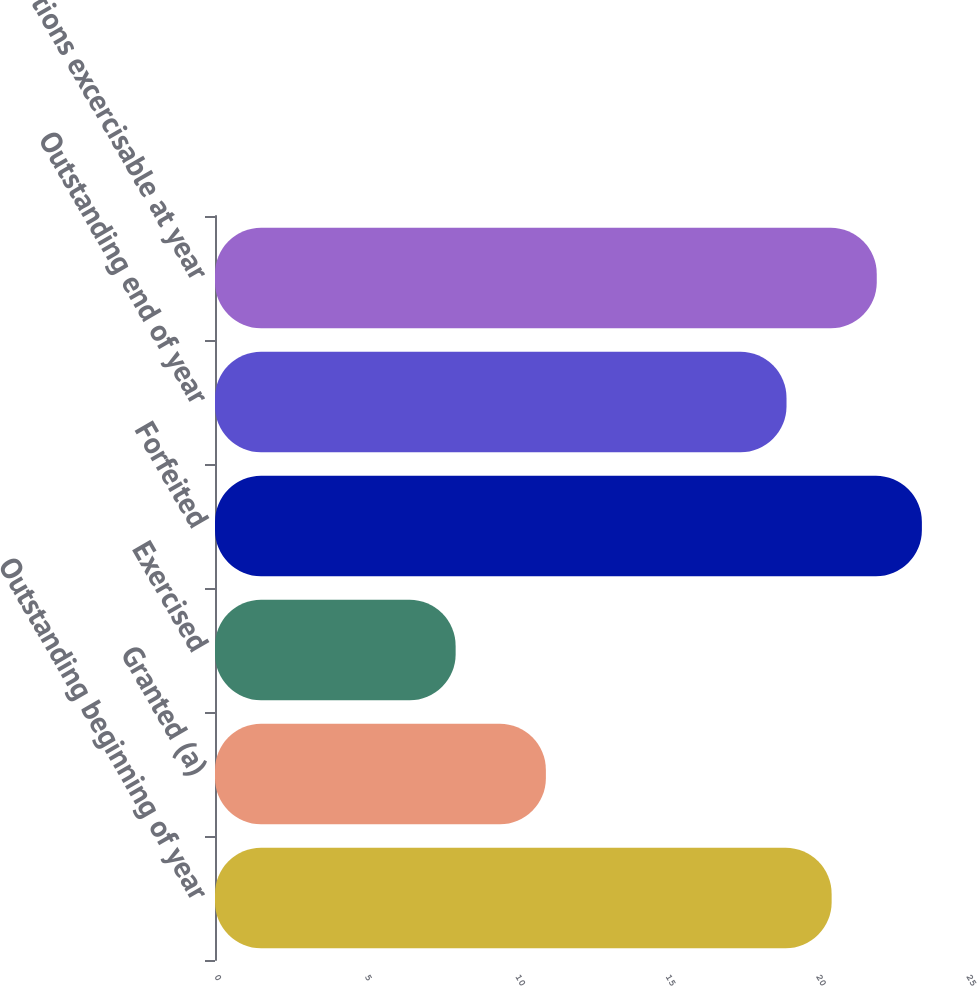Convert chart. <chart><loc_0><loc_0><loc_500><loc_500><bar_chart><fcel>Outstanding beginning of year<fcel>Granted (a)<fcel>Exercised<fcel>Forfeited<fcel>Outstanding end of year<fcel>Options excercisable at year<nl><fcel>20.5<fcel>11<fcel>8<fcel>23.5<fcel>19<fcel>22<nl></chart> 